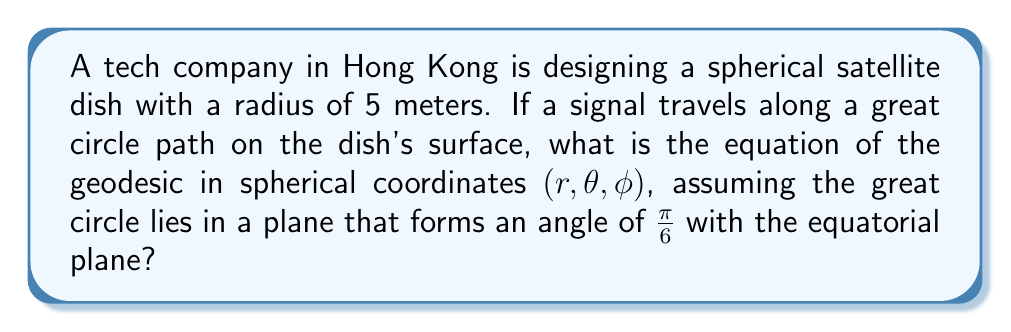Could you help me with this problem? To solve this problem, we'll follow these steps:

1) Recall that on a sphere, geodesics are great circles. The equation of a great circle in spherical coordinates is:

   $$\tan \phi = \tan \alpha \sin(\theta - \theta_0)$$

   where $\alpha$ is the angle between the plane of the great circle and the equatorial plane, and $\theta_0$ is the longitude of a point where the great circle crosses the equator.

2) In this case, we're given that $\alpha = \frac{\pi}{6}$.

3) We can choose $\theta_0 = 0$ without loss of generality, as it just determines the starting point of our coordinate system.

4) Substituting these values into the equation:

   $$\tan \phi = \tan(\frac{\pi}{6}) \sin(\theta - 0)$$

5) Simplify:

   $$\tan \phi = \frac{1}{\sqrt{3}} \sin \theta$$

6) This is the equation of the geodesic in terms of $\theta$ and $\phi$. To complete the description in $(r, \theta, \phi)$ coordinates, we need to include the radius:

   $$r = 5$$

   $$\tan \phi = \frac{1}{\sqrt{3}} \sin \theta$$

This fully describes the geodesic on the spherical satellite dish.
Answer: $r = 5$, $\tan \phi = \frac{1}{\sqrt{3}} \sin \theta$ 